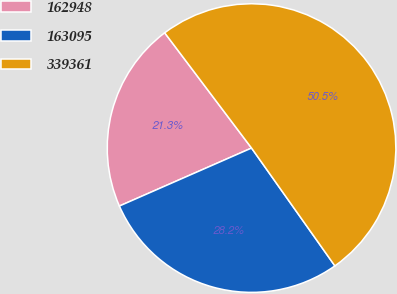Convert chart to OTSL. <chart><loc_0><loc_0><loc_500><loc_500><pie_chart><fcel>162948<fcel>163095<fcel>339361<nl><fcel>21.3%<fcel>28.22%<fcel>50.48%<nl></chart> 